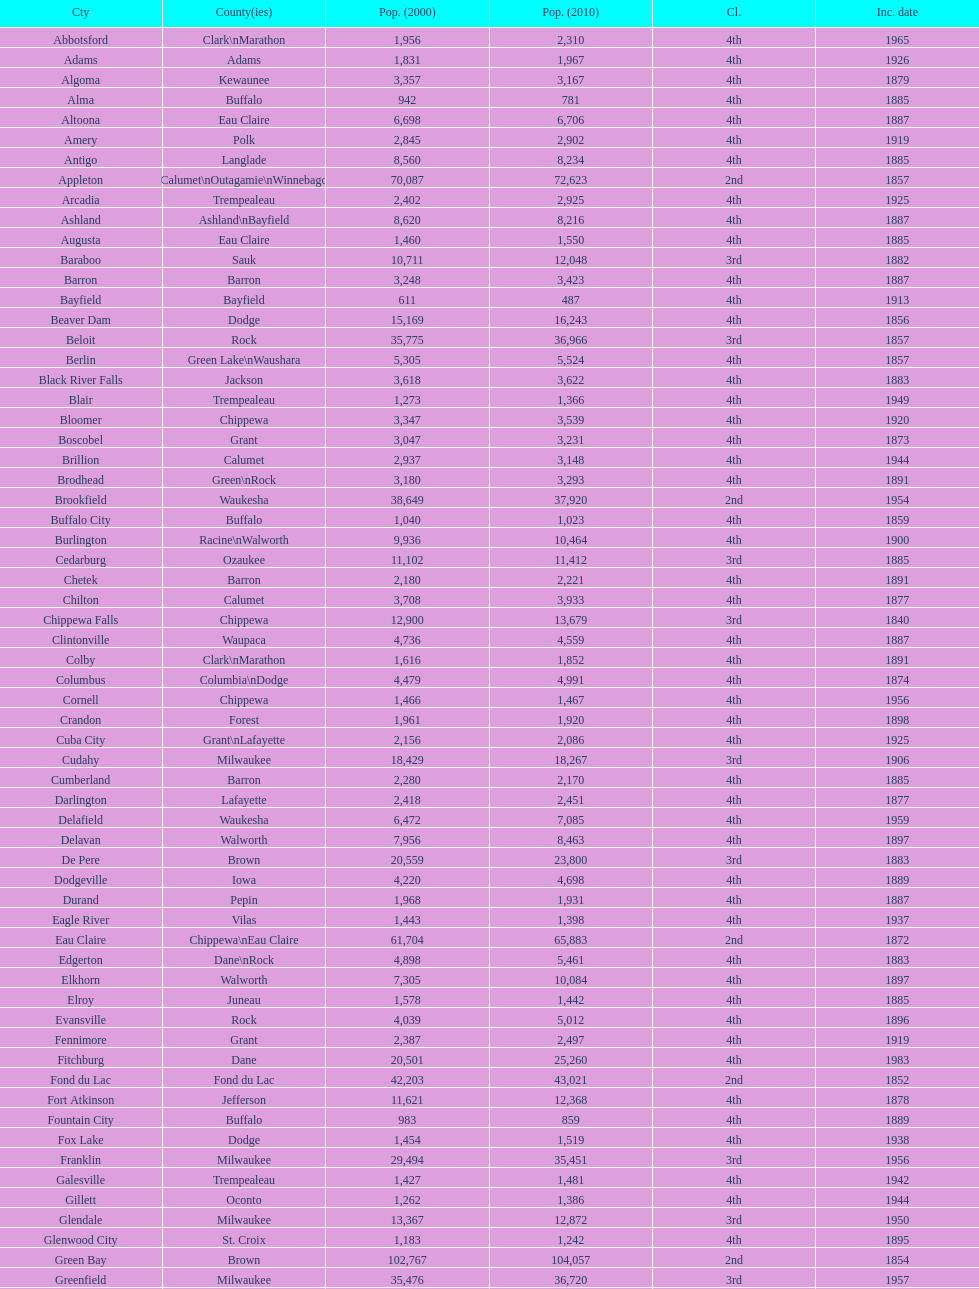Which city in wisconsin is the most populous, based on the 2010 census? Milwaukee. 